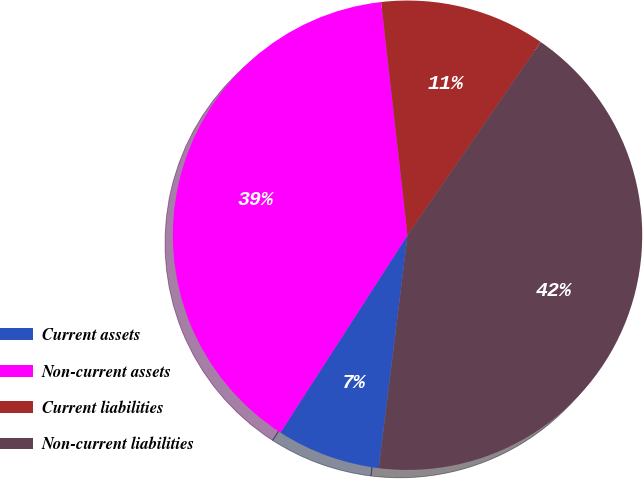Convert chart to OTSL. <chart><loc_0><loc_0><loc_500><loc_500><pie_chart><fcel>Current assets<fcel>Non-current assets<fcel>Current liabilities<fcel>Non-current liabilities<nl><fcel>7.15%<fcel>39.1%<fcel>11.4%<fcel>42.35%<nl></chart> 